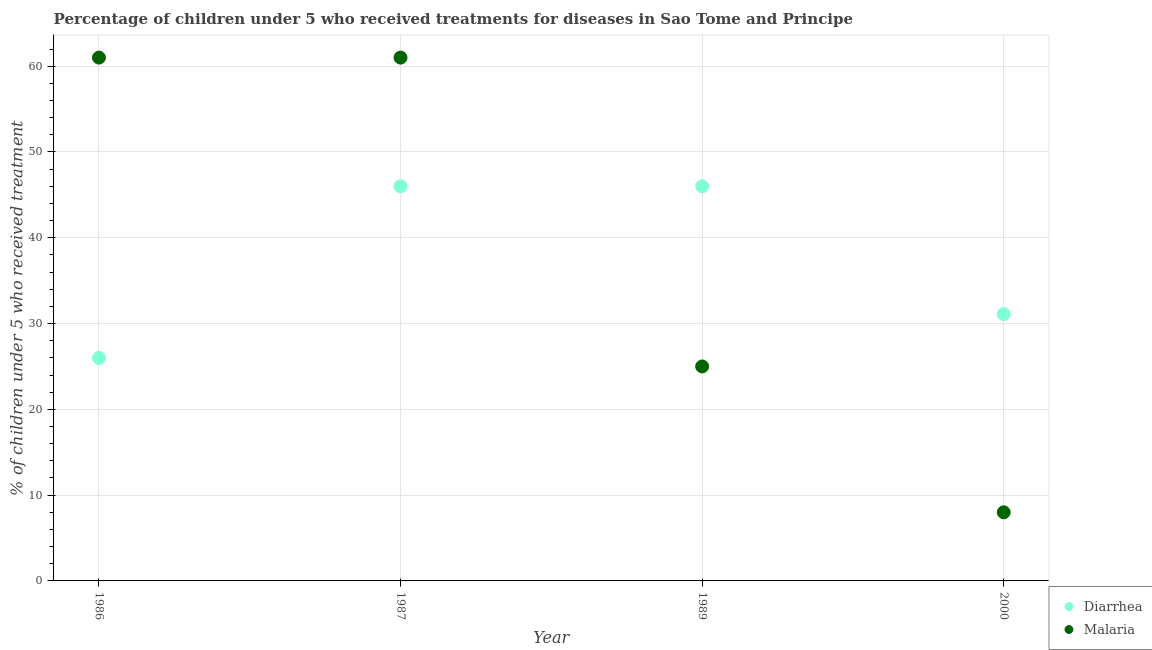How many different coloured dotlines are there?
Provide a short and direct response. 2. Is the number of dotlines equal to the number of legend labels?
Offer a very short reply. Yes. What is the percentage of children who received treatment for diarrhoea in 1989?
Give a very brief answer. 46. Across all years, what is the maximum percentage of children who received treatment for diarrhoea?
Your answer should be very brief. 46. Across all years, what is the minimum percentage of children who received treatment for diarrhoea?
Provide a succinct answer. 26. In which year was the percentage of children who received treatment for malaria maximum?
Keep it short and to the point. 1986. What is the total percentage of children who received treatment for diarrhoea in the graph?
Offer a terse response. 149.1. What is the difference between the percentage of children who received treatment for malaria in 1987 and the percentage of children who received treatment for diarrhoea in 1986?
Give a very brief answer. 35. What is the average percentage of children who received treatment for diarrhoea per year?
Provide a short and direct response. 37.27. In the year 1987, what is the difference between the percentage of children who received treatment for malaria and percentage of children who received treatment for diarrhoea?
Your response must be concise. 15. In how many years, is the percentage of children who received treatment for malaria greater than 18 %?
Ensure brevity in your answer.  3. What is the ratio of the percentage of children who received treatment for malaria in 1986 to that in 2000?
Make the answer very short. 7.62. Is the percentage of children who received treatment for diarrhoea in 1986 less than that in 2000?
Ensure brevity in your answer.  Yes. Is the difference between the percentage of children who received treatment for diarrhoea in 1986 and 1989 greater than the difference between the percentage of children who received treatment for malaria in 1986 and 1989?
Offer a terse response. No. What is the difference between the highest and the lowest percentage of children who received treatment for diarrhoea?
Ensure brevity in your answer.  20. Is the sum of the percentage of children who received treatment for diarrhoea in 1986 and 1989 greater than the maximum percentage of children who received treatment for malaria across all years?
Make the answer very short. Yes. Is the percentage of children who received treatment for diarrhoea strictly greater than the percentage of children who received treatment for malaria over the years?
Make the answer very short. No. Does the graph contain grids?
Provide a succinct answer. Yes. What is the title of the graph?
Keep it short and to the point. Percentage of children under 5 who received treatments for diseases in Sao Tome and Principe. What is the label or title of the Y-axis?
Make the answer very short. % of children under 5 who received treatment. What is the % of children under 5 who received treatment of Diarrhea in 1986?
Offer a terse response. 26. What is the % of children under 5 who received treatment of Malaria in 1986?
Offer a terse response. 61. What is the % of children under 5 who received treatment in Diarrhea in 2000?
Offer a terse response. 31.1. Across all years, what is the maximum % of children under 5 who received treatment of Diarrhea?
Keep it short and to the point. 46. Across all years, what is the minimum % of children under 5 who received treatment in Malaria?
Provide a short and direct response. 8. What is the total % of children under 5 who received treatment in Diarrhea in the graph?
Make the answer very short. 149.1. What is the total % of children under 5 who received treatment in Malaria in the graph?
Your response must be concise. 155. What is the difference between the % of children under 5 who received treatment of Diarrhea in 1986 and that in 1989?
Offer a terse response. -20. What is the difference between the % of children under 5 who received treatment in Malaria in 1986 and that in 1989?
Your answer should be very brief. 36. What is the difference between the % of children under 5 who received treatment of Diarrhea in 1987 and that in 1989?
Keep it short and to the point. 0. What is the difference between the % of children under 5 who received treatment of Diarrhea in 1989 and that in 2000?
Provide a short and direct response. 14.9. What is the difference between the % of children under 5 who received treatment in Diarrhea in 1986 and the % of children under 5 who received treatment in Malaria in 1987?
Offer a terse response. -35. What is the difference between the % of children under 5 who received treatment of Diarrhea in 1986 and the % of children under 5 who received treatment of Malaria in 1989?
Keep it short and to the point. 1. What is the difference between the % of children under 5 who received treatment in Diarrhea in 1987 and the % of children under 5 who received treatment in Malaria in 1989?
Your response must be concise. 21. What is the difference between the % of children under 5 who received treatment in Diarrhea in 1987 and the % of children under 5 who received treatment in Malaria in 2000?
Make the answer very short. 38. What is the average % of children under 5 who received treatment of Diarrhea per year?
Provide a succinct answer. 37.27. What is the average % of children under 5 who received treatment of Malaria per year?
Ensure brevity in your answer.  38.75. In the year 1986, what is the difference between the % of children under 5 who received treatment of Diarrhea and % of children under 5 who received treatment of Malaria?
Give a very brief answer. -35. In the year 1987, what is the difference between the % of children under 5 who received treatment in Diarrhea and % of children under 5 who received treatment in Malaria?
Provide a short and direct response. -15. In the year 2000, what is the difference between the % of children under 5 who received treatment of Diarrhea and % of children under 5 who received treatment of Malaria?
Your response must be concise. 23.1. What is the ratio of the % of children under 5 who received treatment of Diarrhea in 1986 to that in 1987?
Make the answer very short. 0.57. What is the ratio of the % of children under 5 who received treatment in Diarrhea in 1986 to that in 1989?
Make the answer very short. 0.57. What is the ratio of the % of children under 5 who received treatment in Malaria in 1986 to that in 1989?
Offer a very short reply. 2.44. What is the ratio of the % of children under 5 who received treatment in Diarrhea in 1986 to that in 2000?
Offer a very short reply. 0.84. What is the ratio of the % of children under 5 who received treatment of Malaria in 1986 to that in 2000?
Provide a short and direct response. 7.62. What is the ratio of the % of children under 5 who received treatment in Diarrhea in 1987 to that in 1989?
Your answer should be compact. 1. What is the ratio of the % of children under 5 who received treatment of Malaria in 1987 to that in 1989?
Keep it short and to the point. 2.44. What is the ratio of the % of children under 5 who received treatment in Diarrhea in 1987 to that in 2000?
Offer a terse response. 1.48. What is the ratio of the % of children under 5 who received treatment of Malaria in 1987 to that in 2000?
Offer a terse response. 7.62. What is the ratio of the % of children under 5 who received treatment in Diarrhea in 1989 to that in 2000?
Provide a short and direct response. 1.48. What is the ratio of the % of children under 5 who received treatment of Malaria in 1989 to that in 2000?
Provide a short and direct response. 3.12. What is the difference between the highest and the second highest % of children under 5 who received treatment of Malaria?
Offer a very short reply. 0. What is the difference between the highest and the lowest % of children under 5 who received treatment in Diarrhea?
Provide a succinct answer. 20. What is the difference between the highest and the lowest % of children under 5 who received treatment of Malaria?
Your response must be concise. 53. 